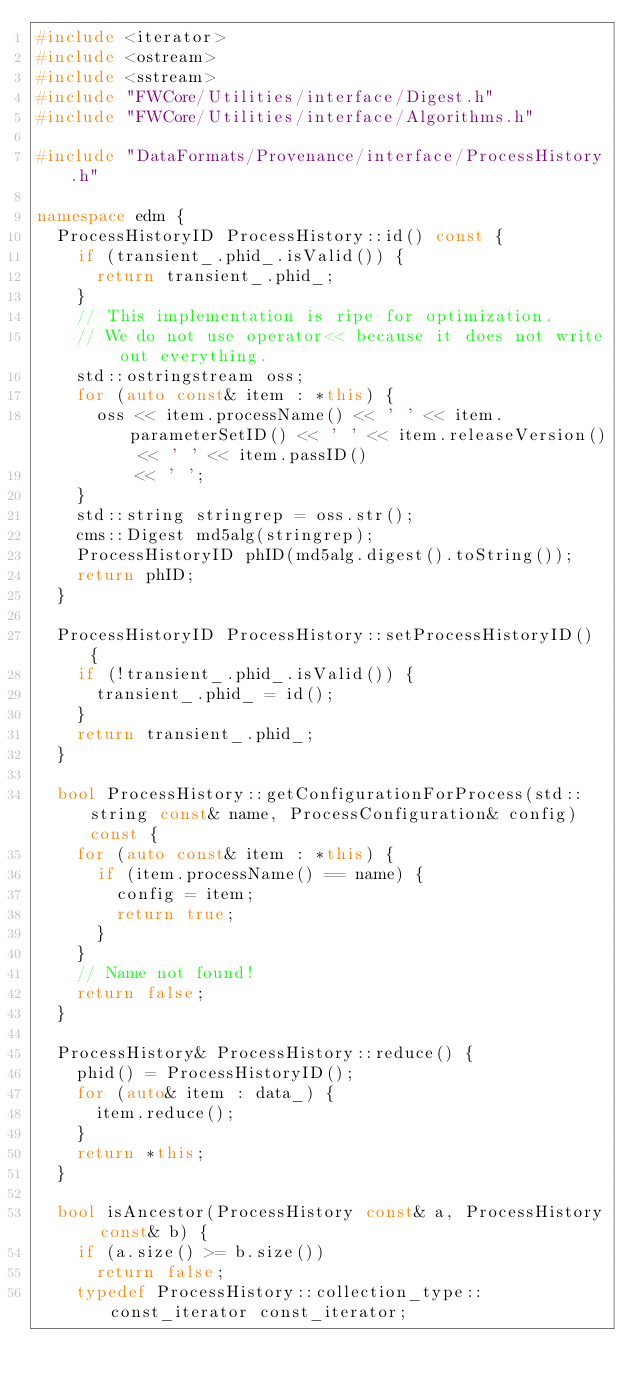Convert code to text. <code><loc_0><loc_0><loc_500><loc_500><_C++_>#include <iterator>
#include <ostream>
#include <sstream>
#include "FWCore/Utilities/interface/Digest.h"
#include "FWCore/Utilities/interface/Algorithms.h"

#include "DataFormats/Provenance/interface/ProcessHistory.h"

namespace edm {
  ProcessHistoryID ProcessHistory::id() const {
    if (transient_.phid_.isValid()) {
      return transient_.phid_;
    }
    // This implementation is ripe for optimization.
    // We do not use operator<< because it does not write out everything.
    std::ostringstream oss;
    for (auto const& item : *this) {
      oss << item.processName() << ' ' << item.parameterSetID() << ' ' << item.releaseVersion() << ' ' << item.passID()
          << ' ';
    }
    std::string stringrep = oss.str();
    cms::Digest md5alg(stringrep);
    ProcessHistoryID phID(md5alg.digest().toString());
    return phID;
  }

  ProcessHistoryID ProcessHistory::setProcessHistoryID() {
    if (!transient_.phid_.isValid()) {
      transient_.phid_ = id();
    }
    return transient_.phid_;
  }

  bool ProcessHistory::getConfigurationForProcess(std::string const& name, ProcessConfiguration& config) const {
    for (auto const& item : *this) {
      if (item.processName() == name) {
        config = item;
        return true;
      }
    }
    // Name not found!
    return false;
  }

  ProcessHistory& ProcessHistory::reduce() {
    phid() = ProcessHistoryID();
    for (auto& item : data_) {
      item.reduce();
    }
    return *this;
  }

  bool isAncestor(ProcessHistory const& a, ProcessHistory const& b) {
    if (a.size() >= b.size())
      return false;
    typedef ProcessHistory::collection_type::const_iterator const_iterator;</code> 